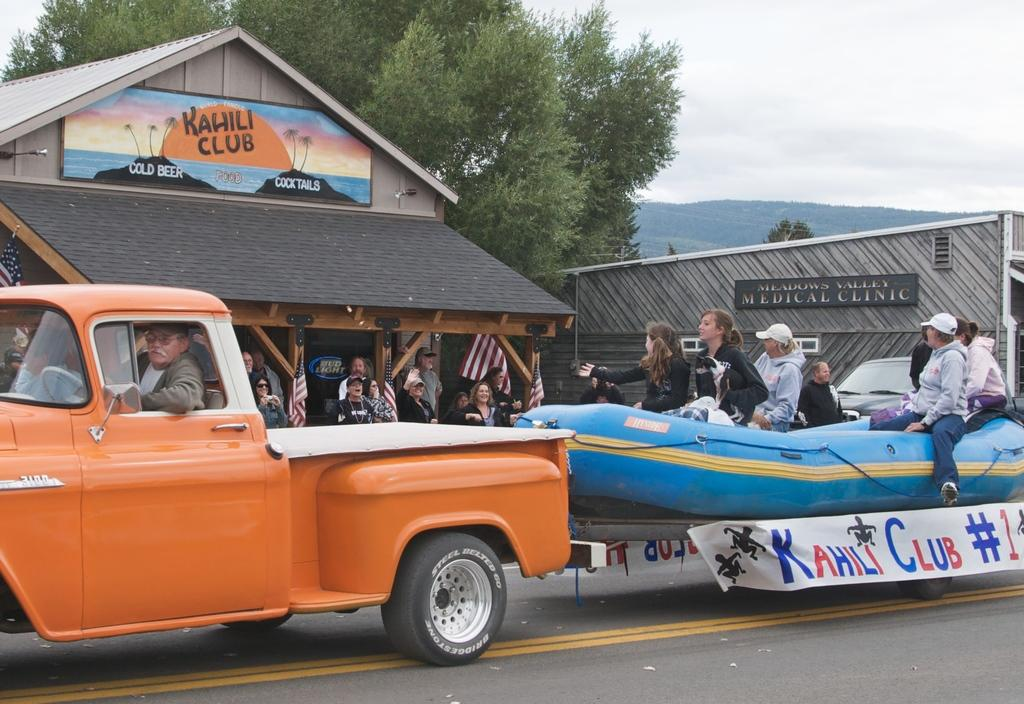What type of structures are present in the image? There are sheds in the image. What else can be seen besides the sheds? There is a vehicle, a tub, trees, and hills in the image. What is visible in the background of the image? The sky is visible in the image. Where is the throne located in the image? There is no throne present in the image. What color is the orange in the image? There is no orange present in the image. 